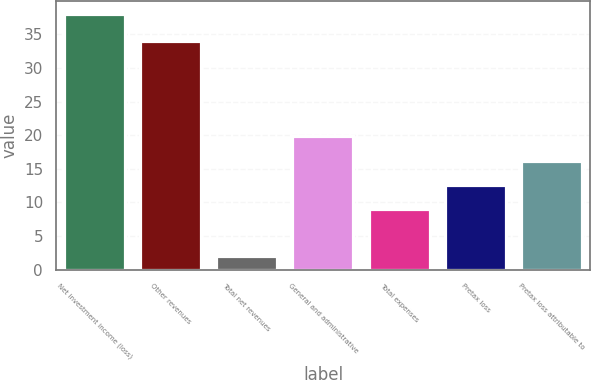Convert chart to OTSL. <chart><loc_0><loc_0><loc_500><loc_500><bar_chart><fcel>Net investment income (loss)<fcel>Other revenues<fcel>Total net revenues<fcel>General and administrative<fcel>Total expenses<fcel>Pretax loss<fcel>Pretax loss attributable to<nl><fcel>38<fcel>34<fcel>2<fcel>19.8<fcel>9<fcel>12.6<fcel>16.2<nl></chart> 